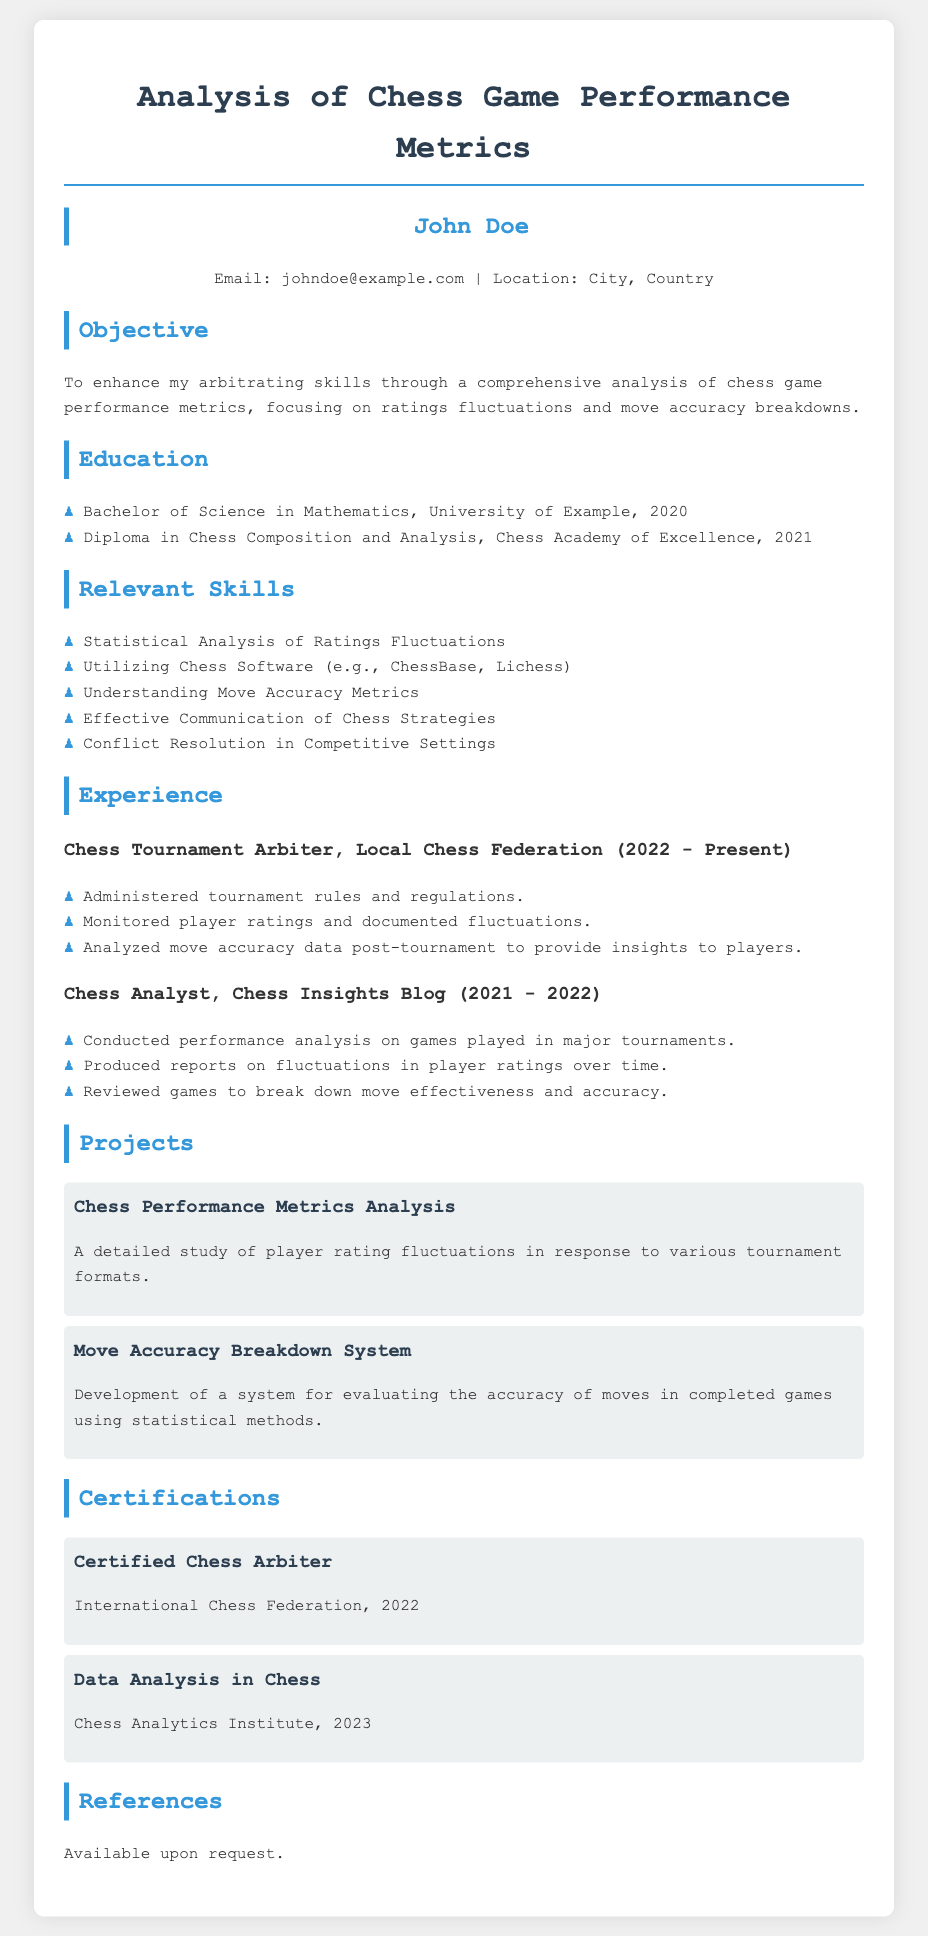What is the name of the individual in the CV? The CV presents John Doe as the individual's name, prominently displayed at the top.
Answer: John Doe What is John Doe's email address? The contact details section of the CV includes the email address johndoe@example.com.
Answer: johndoe@example.com Which year did John Doe graduate with a Bachelor of Science in Mathematics? The education section specifies that he graduated in 2020.
Answer: 2020 How many years of experience does John Doe have as a Chess Tournament Arbiter? The CV states he has been in this role from 2022 to present, indicating he has at least one year of experience.
Answer: 1 year What is one of John Doe's relevant skills? The skills section lists abilities such as "Statistical Analysis of Ratings Fluctuations."
Answer: Statistical Analysis of Ratings Fluctuations In which year did John Doe obtain the Certified Chess Arbiter certification? This certification was awarded in the year 2022, as noted in the certifications section.
Answer: 2022 What project focuses on player rating fluctuations? The project titled "Chess Performance Metrics Analysis" deals specifically with player rating fluctuations.
Answer: Chess Performance Metrics Analysis What organization provided the Data Analysis in Chess certification? The certification was issued by the Chess Analytics Institute, as mentioned in the certifications section.
Answer: Chess Analytics Institute What is the objective stated in the CV? The CV indicates the objective is to enhance arbitrating skills through analysis of chess game performance metrics.
Answer: Enhance arbitrating skills through analysis of chess game performance metrics 